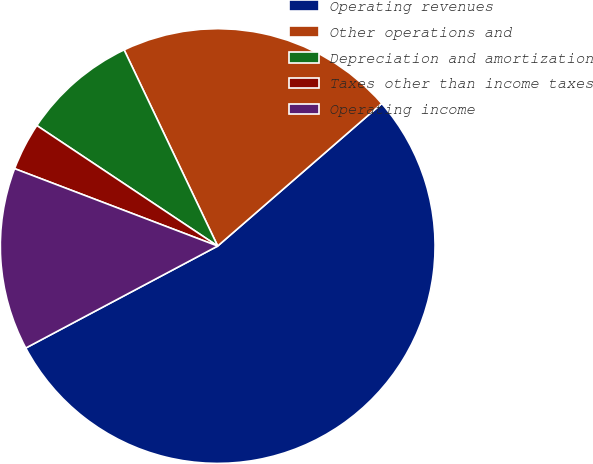Convert chart to OTSL. <chart><loc_0><loc_0><loc_500><loc_500><pie_chart><fcel>Operating revenues<fcel>Other operations and<fcel>Depreciation and amortization<fcel>Taxes other than income taxes<fcel>Operating income<nl><fcel>53.61%<fcel>20.7%<fcel>8.56%<fcel>3.56%<fcel>13.57%<nl></chart> 